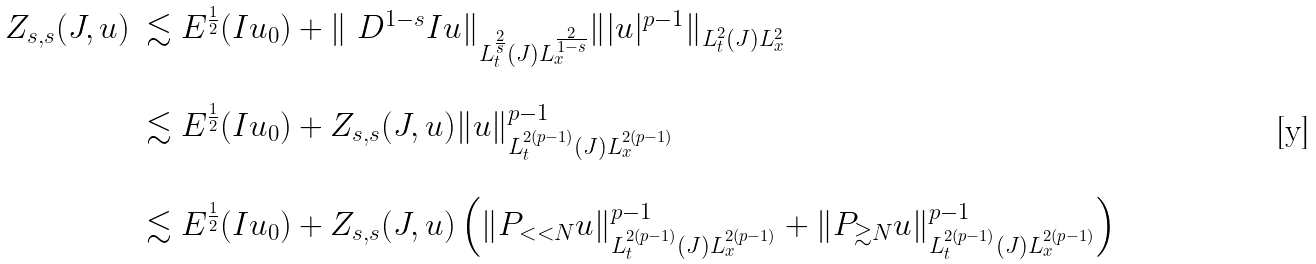Convert formula to latex. <formula><loc_0><loc_0><loc_500><loc_500>\begin{array} { l l } Z _ { s , s } ( J , u ) & \lesssim E ^ { \frac { 1 } { 2 } } ( I u _ { 0 } ) + \| \ D ^ { 1 - s } I u \| _ { L _ { t } ^ { \frac { 2 } { s } } ( J ) L _ { x } ^ { \frac { 2 } { 1 - s } } } \| | u | ^ { p - 1 } \| _ { L _ { t } ^ { 2 } ( J ) L _ { x } ^ { 2 } } \\ & \\ & \lesssim E ^ { \frac { 1 } { 2 } } ( I u _ { 0 } ) + Z _ { s , s } ( J , u ) \| u \| ^ { p - 1 } _ { L _ { t } ^ { 2 ( p - 1 ) } ( J ) L _ { x } ^ { 2 ( p - 1 ) } } \\ & \\ & \lesssim E ^ { \frac { 1 } { 2 } } ( I u _ { 0 } ) + Z _ { s , s } ( J , u ) \left ( \| P _ { < < N } u \| ^ { p - 1 } _ { L _ { t } ^ { 2 ( p - 1 ) } ( J ) L _ { x } ^ { 2 ( p - 1 ) } } + \| P _ { \gtrsim N } u \| ^ { p - 1 } _ { L _ { t } ^ { 2 ( p - 1 ) } ( J ) L _ { x } ^ { 2 ( p - 1 ) } } \right ) \\ \end{array}</formula> 